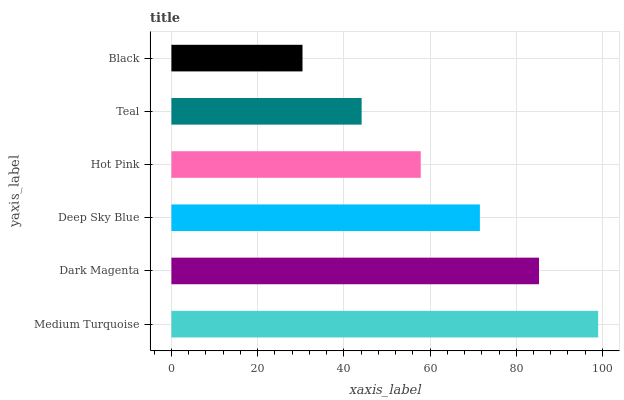Is Black the minimum?
Answer yes or no. Yes. Is Medium Turquoise the maximum?
Answer yes or no. Yes. Is Dark Magenta the minimum?
Answer yes or no. No. Is Dark Magenta the maximum?
Answer yes or no. No. Is Medium Turquoise greater than Dark Magenta?
Answer yes or no. Yes. Is Dark Magenta less than Medium Turquoise?
Answer yes or no. Yes. Is Dark Magenta greater than Medium Turquoise?
Answer yes or no. No. Is Medium Turquoise less than Dark Magenta?
Answer yes or no. No. Is Deep Sky Blue the high median?
Answer yes or no. Yes. Is Hot Pink the low median?
Answer yes or no. Yes. Is Dark Magenta the high median?
Answer yes or no. No. Is Medium Turquoise the low median?
Answer yes or no. No. 